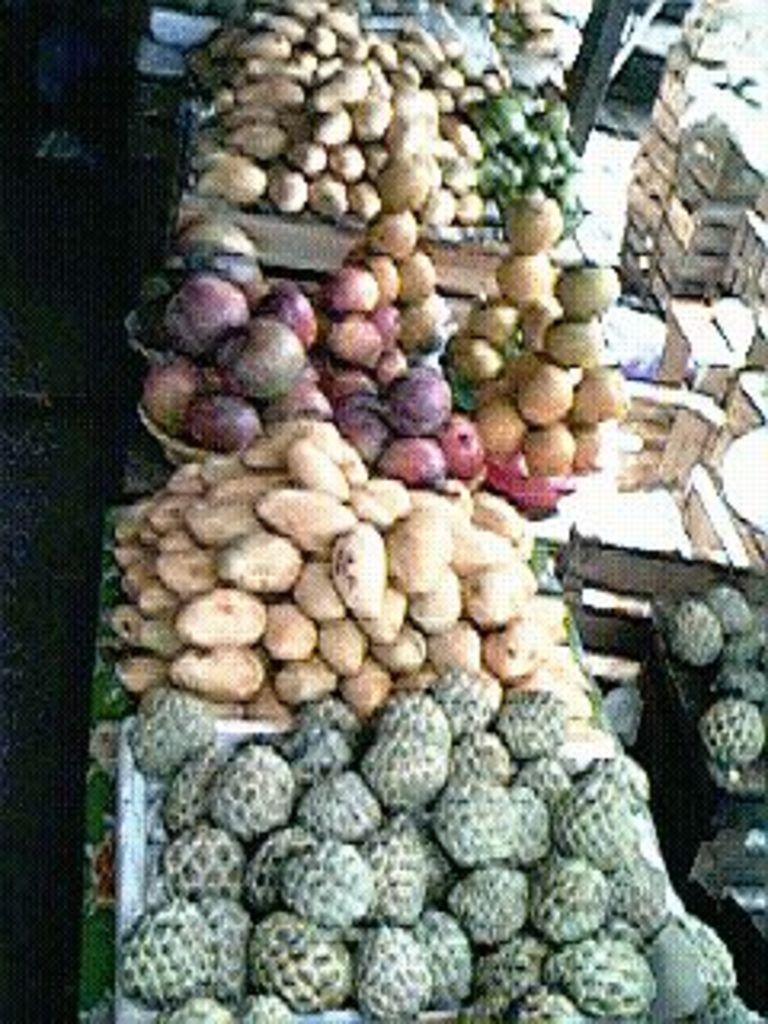How would you summarize this image in a sentence or two? In this picture we can observe some fruits and vegetables in his stall. There are different types of vegetables. On the right side we can observe boxes. 